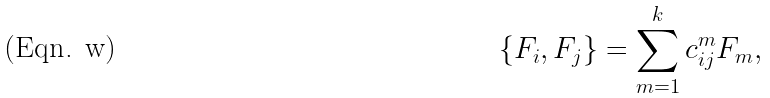Convert formula to latex. <formula><loc_0><loc_0><loc_500><loc_500>\{ F _ { i } , F _ { j } \} = \sum _ { m = 1 } ^ { k } c _ { i j } ^ { m } F _ { m } ,</formula> 